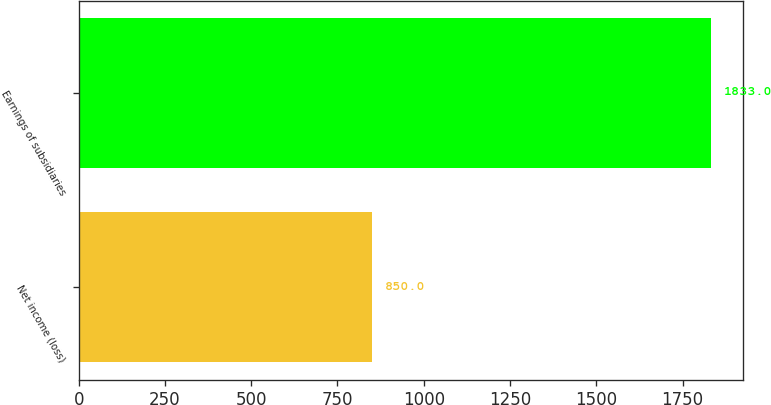<chart> <loc_0><loc_0><loc_500><loc_500><bar_chart><fcel>Net income (loss)<fcel>Earnings of subsidiaries<nl><fcel>850<fcel>1833<nl></chart> 